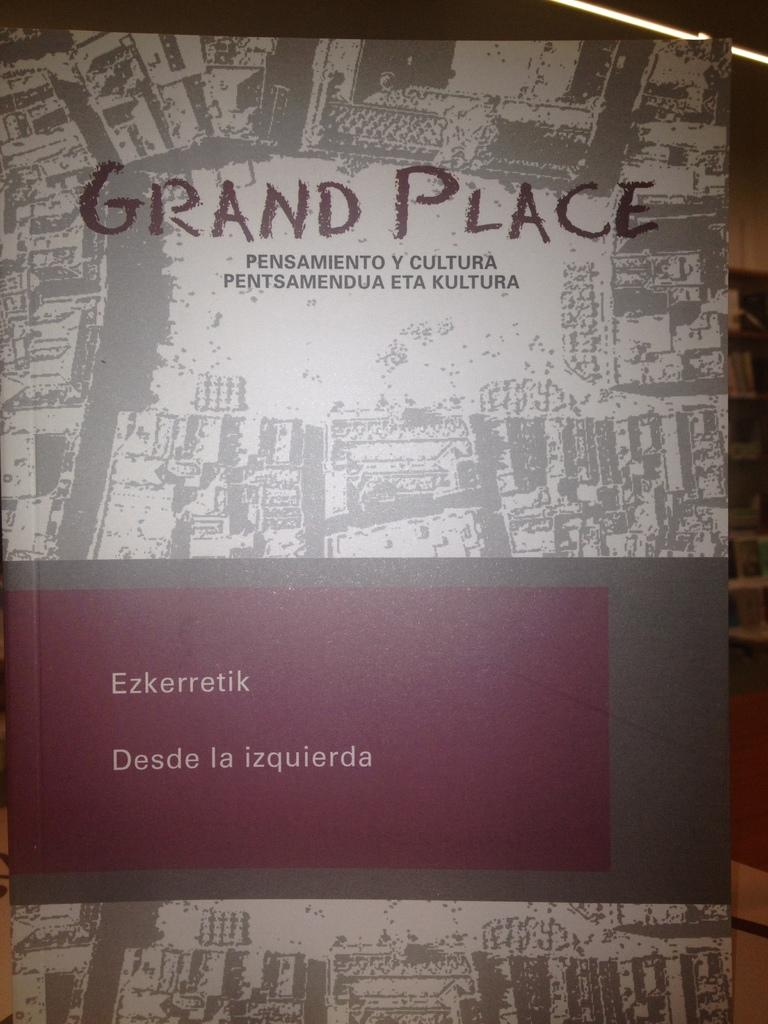<image>
Offer a succinct explanation of the picture presented. A large sign says "grand place" at the top. 